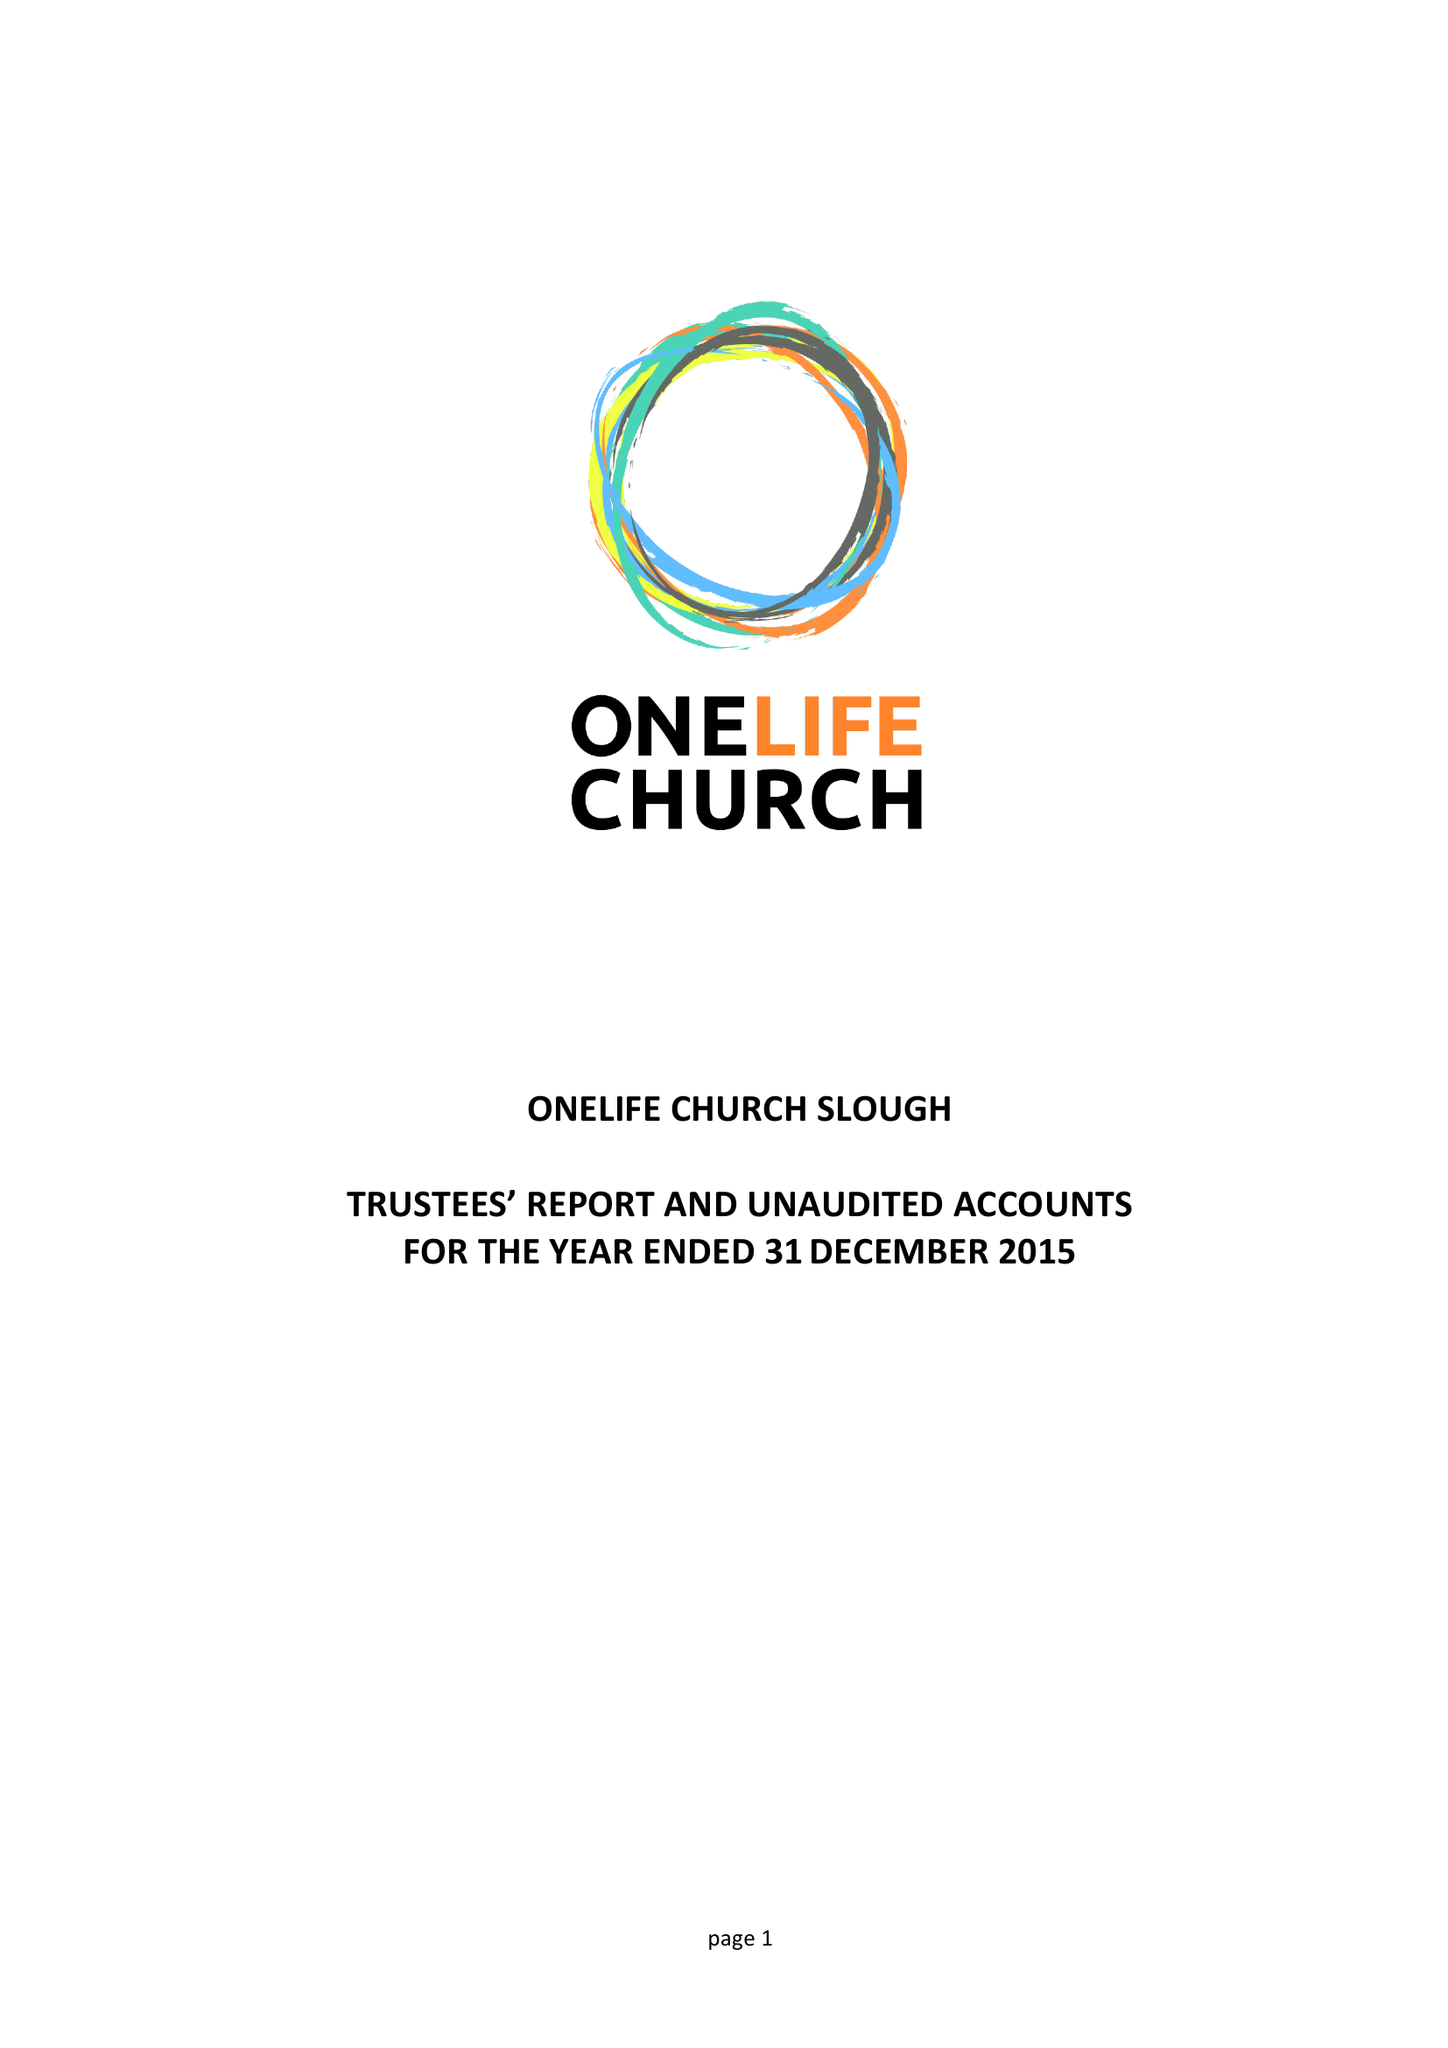What is the value for the spending_annually_in_british_pounds?
Answer the question using a single word or phrase. 22865.00 